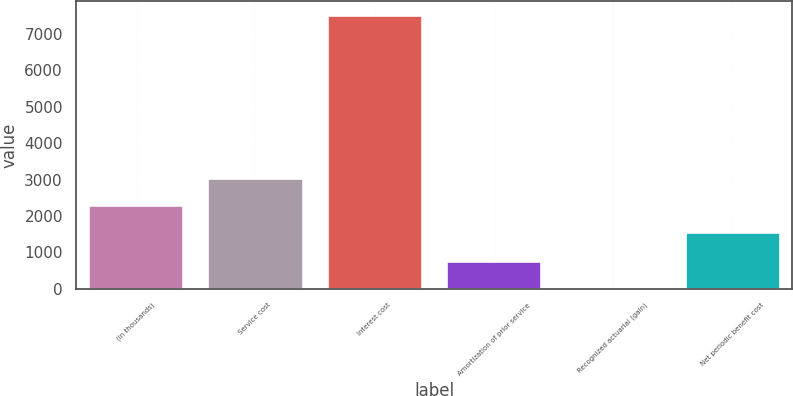<chart> <loc_0><loc_0><loc_500><loc_500><bar_chart><fcel>(In thousands)<fcel>Service cost<fcel>Interest cost<fcel>Amortization of prior service<fcel>Recognized actuarial (gain)<fcel>Net periodic benefit cost<nl><fcel>2303<fcel>3055<fcel>7527<fcel>759<fcel>7<fcel>1551<nl></chart> 